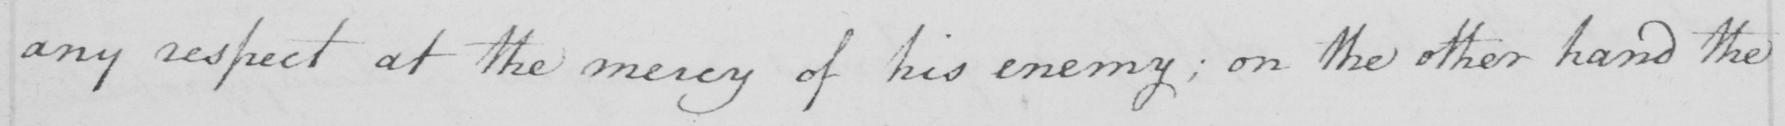Please transcribe the handwritten text in this image. any respect at the mercy of his enemy ; on the other hand the 